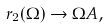<formula> <loc_0><loc_0><loc_500><loc_500>r _ { 2 } ( \Omega ) \rightarrow \Omega A ,</formula> 